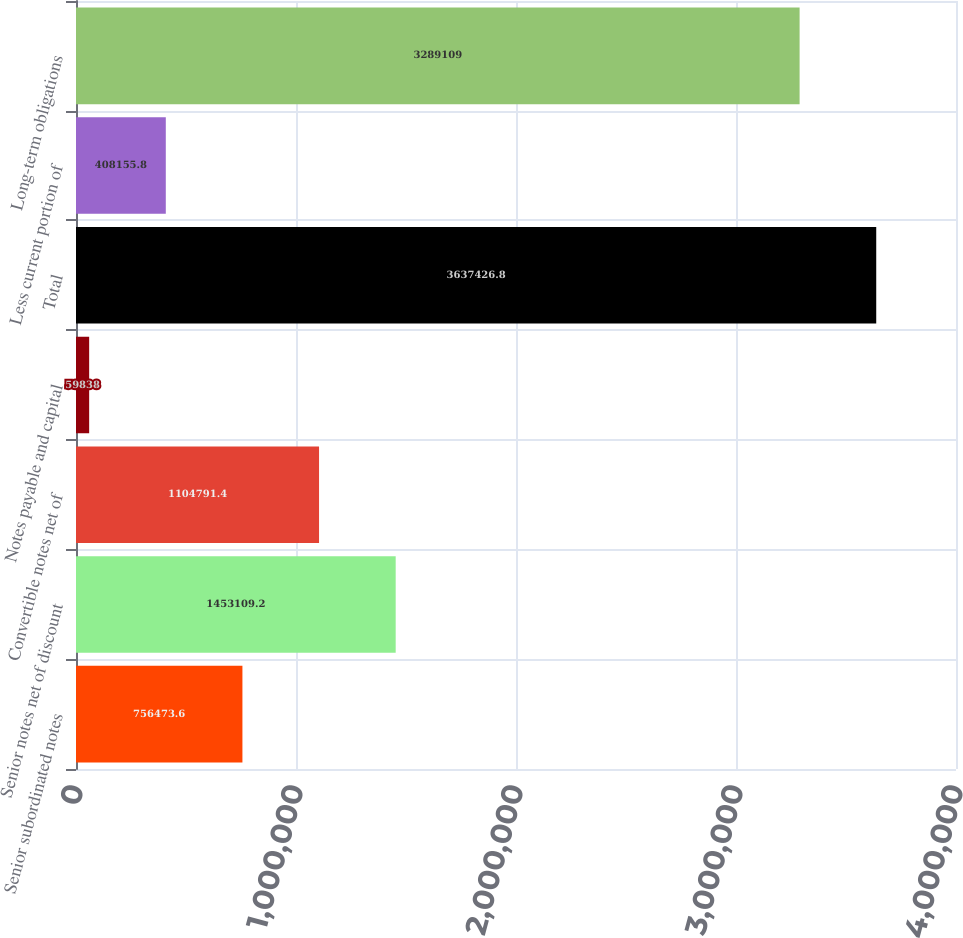Convert chart. <chart><loc_0><loc_0><loc_500><loc_500><bar_chart><fcel>Senior subordinated notes<fcel>Senior notes net of discount<fcel>Convertible notes net of<fcel>Notes payable and capital<fcel>Total<fcel>Less current portion of<fcel>Long-term obligations<nl><fcel>756474<fcel>1.45311e+06<fcel>1.10479e+06<fcel>59838<fcel>3.63743e+06<fcel>408156<fcel>3.28911e+06<nl></chart> 